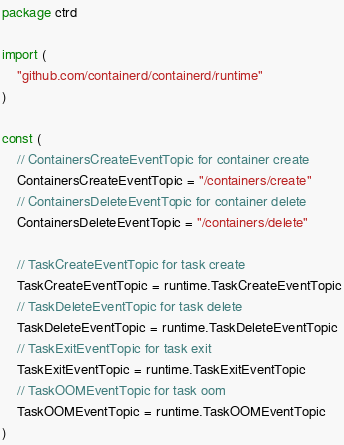Convert code to text. <code><loc_0><loc_0><loc_500><loc_500><_Go_>package ctrd

import (
	"github.com/containerd/containerd/runtime"
)

const (
	// ContainersCreateEventTopic for container create
	ContainersCreateEventTopic = "/containers/create"
	// ContainersDeleteEventTopic for container delete
	ContainersDeleteEventTopic = "/containers/delete"

	// TaskCreateEventTopic for task create
	TaskCreateEventTopic = runtime.TaskCreateEventTopic
	// TaskDeleteEventTopic for task delete
	TaskDeleteEventTopic = runtime.TaskDeleteEventTopic
	// TaskExitEventTopic for task exit
	TaskExitEventTopic = runtime.TaskExitEventTopic
	// TaskOOMEventTopic for task oom
	TaskOOMEventTopic = runtime.TaskOOMEventTopic
)
</code> 